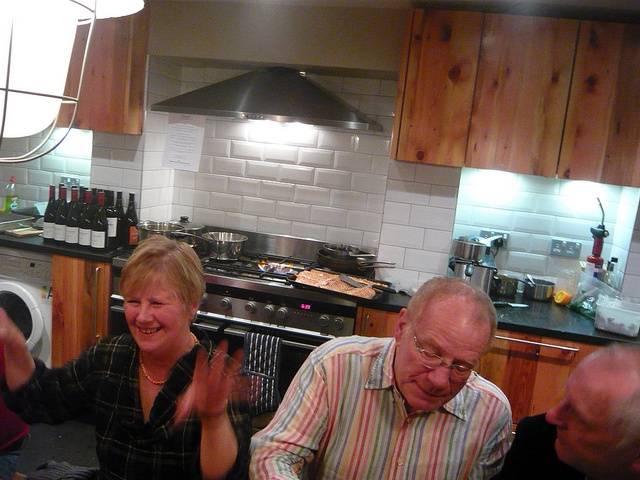Describe the objects in this image and their specific colors. I can see people in white, brown, gray, darkgray, and maroon tones, people in white, black, maroon, and brown tones, oven in white, black, gray, maroon, and darkgray tones, people in white, black, maroon, and brown tones, and bowl in white, black, gray, and darkgray tones in this image. 